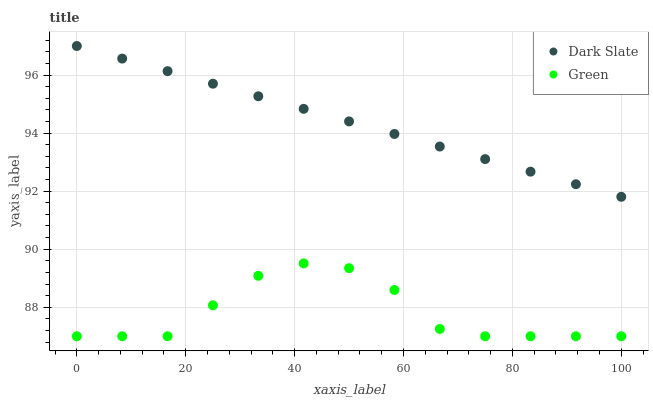Does Green have the minimum area under the curve?
Answer yes or no. Yes. Does Dark Slate have the maximum area under the curve?
Answer yes or no. Yes. Does Green have the maximum area under the curve?
Answer yes or no. No. Is Dark Slate the smoothest?
Answer yes or no. Yes. Is Green the roughest?
Answer yes or no. Yes. Is Green the smoothest?
Answer yes or no. No. Does Green have the lowest value?
Answer yes or no. Yes. Does Dark Slate have the highest value?
Answer yes or no. Yes. Does Green have the highest value?
Answer yes or no. No. Is Green less than Dark Slate?
Answer yes or no. Yes. Is Dark Slate greater than Green?
Answer yes or no. Yes. Does Green intersect Dark Slate?
Answer yes or no. No. 